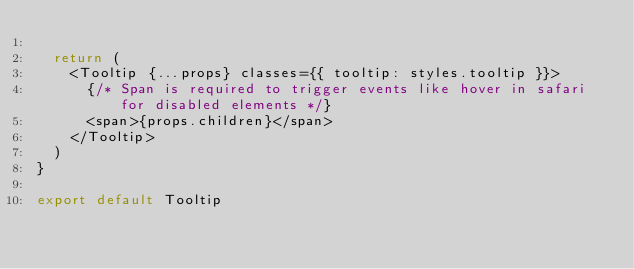<code> <loc_0><loc_0><loc_500><loc_500><_TypeScript_>
  return (
    <Tooltip {...props} classes={{ tooltip: styles.tooltip }}>
      {/* Span is required to trigger events like hover in safari for disabled elements */}
      <span>{props.children}</span>
    </Tooltip>
  )
}

export default Tooltip
</code> 